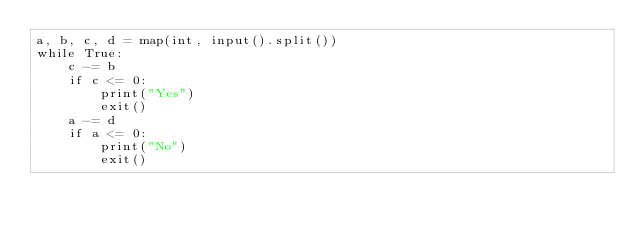Convert code to text. <code><loc_0><loc_0><loc_500><loc_500><_Python_>a, b, c, d = map(int, input().split())
while True:
    c -= b
    if c <= 0:
        print("Yes")
        exit()
    a -= d
    if a <= 0:
        print("No")
        exit()</code> 